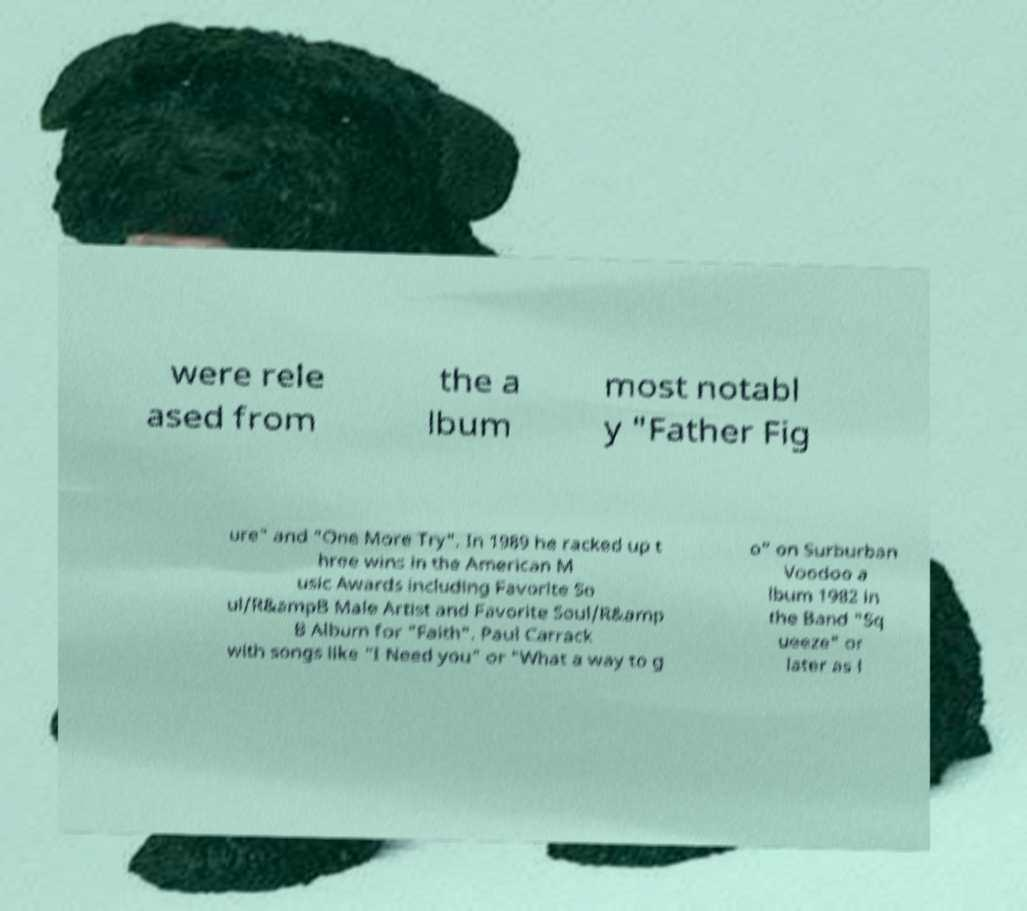Can you accurately transcribe the text from the provided image for me? were rele ased from the a lbum most notabl y "Father Fig ure" and "One More Try". In 1989 he racked up t hree wins in the American M usic Awards including Favorite So ul/R&ampB Male Artist and Favorite Soul/R&amp B Album for "Faith". Paul Carrack with songs like "I Need you" or "What a way to g o" on Surburban Voodoo a lbum 1982 in the Band "Sq ueeze" or later as l 